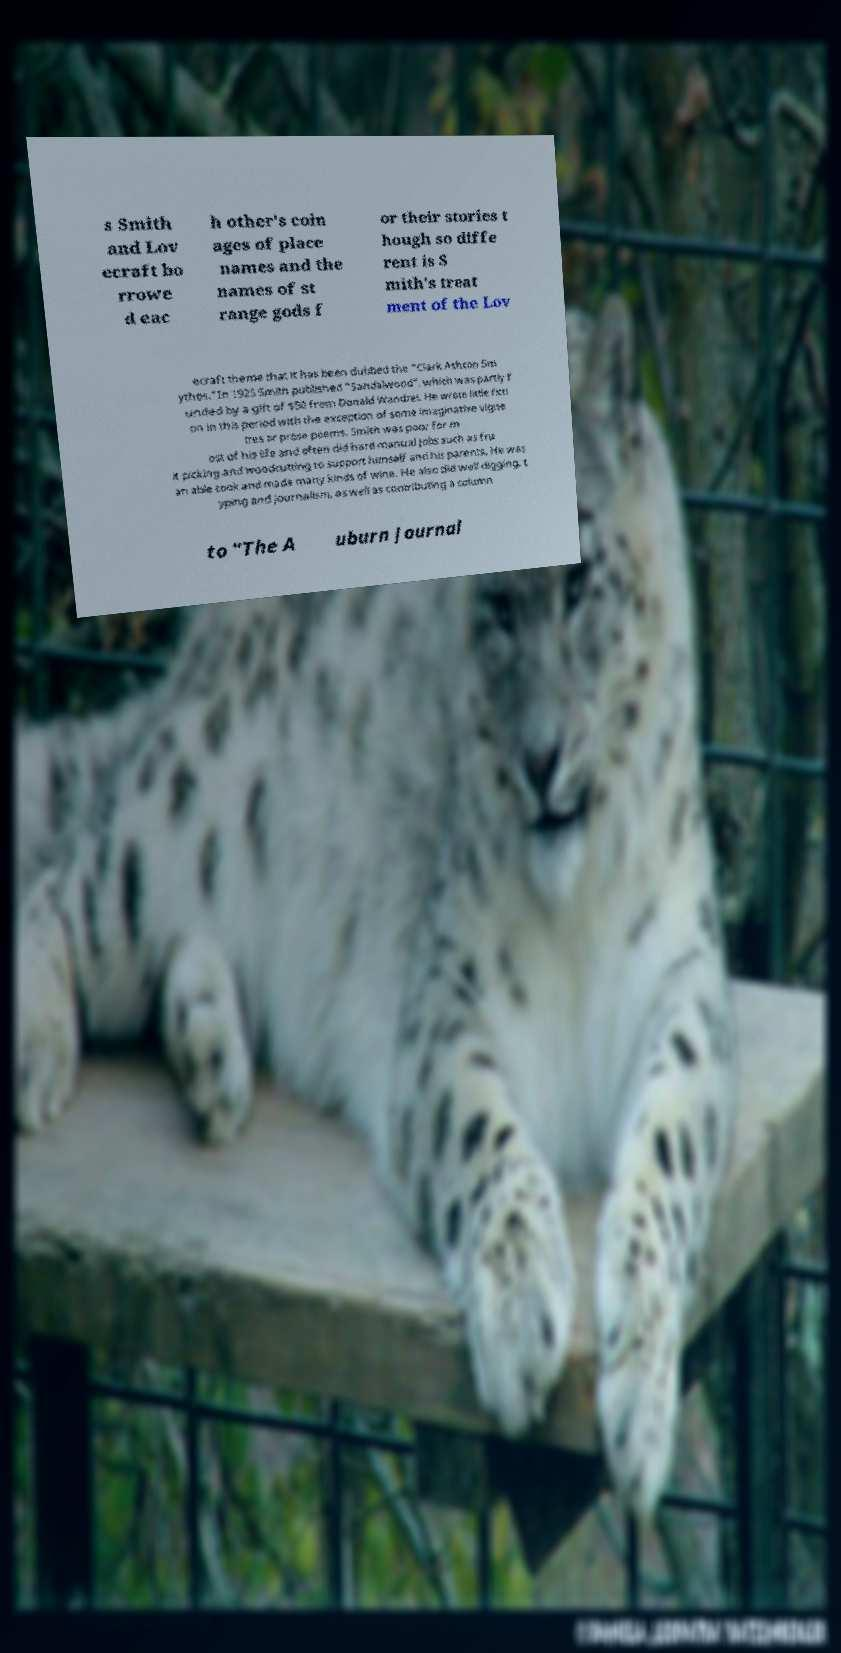Could you extract and type out the text from this image? s Smith and Lov ecraft bo rrowe d eac h other's coin ages of place names and the names of st range gods f or their stories t hough so diffe rent is S mith's treat ment of the Lov ecraft theme that it has been dubbed the "Clark Ashton Sm ythos."In 1925 Smith published "Sandalwood", which was partly f unded by a gift of $50 from Donald Wandrei. He wrote little ficti on in this period with the exception of some imaginative vigne ttes or prose poems. Smith was poor for m ost of his life and often did hard manual jobs such as fru it picking and woodcutting to support himself and his parents. He was an able cook and made many kinds of wine. He also did well digging, t yping and journalism, as well as contributing a column to "The A uburn Journal 